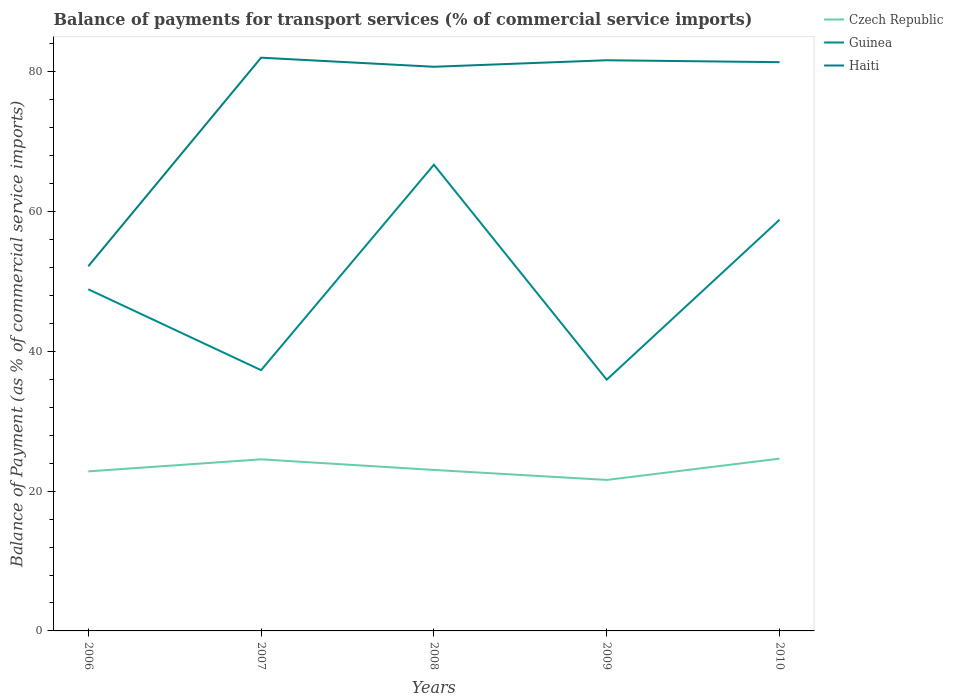Does the line corresponding to Haiti intersect with the line corresponding to Czech Republic?
Offer a terse response. No. Is the number of lines equal to the number of legend labels?
Your answer should be compact. Yes. Across all years, what is the maximum balance of payments for transport services in Haiti?
Provide a succinct answer. 52.17. In which year was the balance of payments for transport services in Czech Republic maximum?
Provide a succinct answer. 2009. What is the total balance of payments for transport services in Haiti in the graph?
Offer a terse response. -29.2. What is the difference between the highest and the second highest balance of payments for transport services in Haiti?
Provide a succinct answer. 29.84. How many lines are there?
Keep it short and to the point. 3. Are the values on the major ticks of Y-axis written in scientific E-notation?
Provide a succinct answer. No. Does the graph contain any zero values?
Your answer should be compact. No. How are the legend labels stacked?
Offer a terse response. Vertical. What is the title of the graph?
Make the answer very short. Balance of payments for transport services (% of commercial service imports). What is the label or title of the X-axis?
Your response must be concise. Years. What is the label or title of the Y-axis?
Provide a short and direct response. Balance of Payment (as % of commercial service imports). What is the Balance of Payment (as % of commercial service imports) of Czech Republic in 2006?
Ensure brevity in your answer.  22.82. What is the Balance of Payment (as % of commercial service imports) in Guinea in 2006?
Your response must be concise. 48.88. What is the Balance of Payment (as % of commercial service imports) of Haiti in 2006?
Provide a short and direct response. 52.17. What is the Balance of Payment (as % of commercial service imports) of Czech Republic in 2007?
Provide a succinct answer. 24.55. What is the Balance of Payment (as % of commercial service imports) in Guinea in 2007?
Keep it short and to the point. 37.31. What is the Balance of Payment (as % of commercial service imports) of Haiti in 2007?
Offer a very short reply. 82.01. What is the Balance of Payment (as % of commercial service imports) in Czech Republic in 2008?
Offer a very short reply. 23.03. What is the Balance of Payment (as % of commercial service imports) in Guinea in 2008?
Make the answer very short. 66.7. What is the Balance of Payment (as % of commercial service imports) in Haiti in 2008?
Keep it short and to the point. 80.71. What is the Balance of Payment (as % of commercial service imports) of Czech Republic in 2009?
Give a very brief answer. 21.6. What is the Balance of Payment (as % of commercial service imports) of Guinea in 2009?
Your response must be concise. 35.94. What is the Balance of Payment (as % of commercial service imports) in Haiti in 2009?
Give a very brief answer. 81.64. What is the Balance of Payment (as % of commercial service imports) of Czech Republic in 2010?
Your answer should be very brief. 24.65. What is the Balance of Payment (as % of commercial service imports) in Guinea in 2010?
Your answer should be very brief. 58.82. What is the Balance of Payment (as % of commercial service imports) in Haiti in 2010?
Offer a very short reply. 81.37. Across all years, what is the maximum Balance of Payment (as % of commercial service imports) in Czech Republic?
Make the answer very short. 24.65. Across all years, what is the maximum Balance of Payment (as % of commercial service imports) in Guinea?
Keep it short and to the point. 66.7. Across all years, what is the maximum Balance of Payment (as % of commercial service imports) of Haiti?
Keep it short and to the point. 82.01. Across all years, what is the minimum Balance of Payment (as % of commercial service imports) of Czech Republic?
Provide a succinct answer. 21.6. Across all years, what is the minimum Balance of Payment (as % of commercial service imports) in Guinea?
Provide a succinct answer. 35.94. Across all years, what is the minimum Balance of Payment (as % of commercial service imports) of Haiti?
Your response must be concise. 52.17. What is the total Balance of Payment (as % of commercial service imports) in Czech Republic in the graph?
Make the answer very short. 116.65. What is the total Balance of Payment (as % of commercial service imports) of Guinea in the graph?
Make the answer very short. 247.64. What is the total Balance of Payment (as % of commercial service imports) in Haiti in the graph?
Your answer should be very brief. 377.9. What is the difference between the Balance of Payment (as % of commercial service imports) in Czech Republic in 2006 and that in 2007?
Your response must be concise. -1.72. What is the difference between the Balance of Payment (as % of commercial service imports) in Guinea in 2006 and that in 2007?
Your answer should be compact. 11.57. What is the difference between the Balance of Payment (as % of commercial service imports) in Haiti in 2006 and that in 2007?
Offer a terse response. -29.84. What is the difference between the Balance of Payment (as % of commercial service imports) of Czech Republic in 2006 and that in 2008?
Provide a succinct answer. -0.2. What is the difference between the Balance of Payment (as % of commercial service imports) in Guinea in 2006 and that in 2008?
Your answer should be very brief. -17.82. What is the difference between the Balance of Payment (as % of commercial service imports) of Haiti in 2006 and that in 2008?
Your answer should be very brief. -28.54. What is the difference between the Balance of Payment (as % of commercial service imports) of Czech Republic in 2006 and that in 2009?
Provide a succinct answer. 1.22. What is the difference between the Balance of Payment (as % of commercial service imports) of Guinea in 2006 and that in 2009?
Offer a terse response. 12.93. What is the difference between the Balance of Payment (as % of commercial service imports) in Haiti in 2006 and that in 2009?
Your answer should be very brief. -29.47. What is the difference between the Balance of Payment (as % of commercial service imports) of Czech Republic in 2006 and that in 2010?
Offer a very short reply. -1.82. What is the difference between the Balance of Payment (as % of commercial service imports) of Guinea in 2006 and that in 2010?
Give a very brief answer. -9.94. What is the difference between the Balance of Payment (as % of commercial service imports) of Haiti in 2006 and that in 2010?
Give a very brief answer. -29.2. What is the difference between the Balance of Payment (as % of commercial service imports) of Czech Republic in 2007 and that in 2008?
Offer a very short reply. 1.52. What is the difference between the Balance of Payment (as % of commercial service imports) in Guinea in 2007 and that in 2008?
Give a very brief answer. -29.39. What is the difference between the Balance of Payment (as % of commercial service imports) of Haiti in 2007 and that in 2008?
Your response must be concise. 1.3. What is the difference between the Balance of Payment (as % of commercial service imports) of Czech Republic in 2007 and that in 2009?
Make the answer very short. 2.95. What is the difference between the Balance of Payment (as % of commercial service imports) of Guinea in 2007 and that in 2009?
Keep it short and to the point. 1.36. What is the difference between the Balance of Payment (as % of commercial service imports) of Haiti in 2007 and that in 2009?
Provide a succinct answer. 0.37. What is the difference between the Balance of Payment (as % of commercial service imports) in Czech Republic in 2007 and that in 2010?
Your answer should be compact. -0.1. What is the difference between the Balance of Payment (as % of commercial service imports) in Guinea in 2007 and that in 2010?
Your answer should be compact. -21.51. What is the difference between the Balance of Payment (as % of commercial service imports) of Haiti in 2007 and that in 2010?
Make the answer very short. 0.64. What is the difference between the Balance of Payment (as % of commercial service imports) of Czech Republic in 2008 and that in 2009?
Give a very brief answer. 1.43. What is the difference between the Balance of Payment (as % of commercial service imports) in Guinea in 2008 and that in 2009?
Your answer should be compact. 30.75. What is the difference between the Balance of Payment (as % of commercial service imports) of Haiti in 2008 and that in 2009?
Keep it short and to the point. -0.93. What is the difference between the Balance of Payment (as % of commercial service imports) of Czech Republic in 2008 and that in 2010?
Provide a short and direct response. -1.62. What is the difference between the Balance of Payment (as % of commercial service imports) in Guinea in 2008 and that in 2010?
Your answer should be compact. 7.88. What is the difference between the Balance of Payment (as % of commercial service imports) of Haiti in 2008 and that in 2010?
Offer a very short reply. -0.66. What is the difference between the Balance of Payment (as % of commercial service imports) of Czech Republic in 2009 and that in 2010?
Give a very brief answer. -3.05. What is the difference between the Balance of Payment (as % of commercial service imports) of Guinea in 2009 and that in 2010?
Provide a short and direct response. -22.88. What is the difference between the Balance of Payment (as % of commercial service imports) in Haiti in 2009 and that in 2010?
Your response must be concise. 0.27. What is the difference between the Balance of Payment (as % of commercial service imports) of Czech Republic in 2006 and the Balance of Payment (as % of commercial service imports) of Guinea in 2007?
Your answer should be compact. -14.48. What is the difference between the Balance of Payment (as % of commercial service imports) in Czech Republic in 2006 and the Balance of Payment (as % of commercial service imports) in Haiti in 2007?
Your response must be concise. -59.18. What is the difference between the Balance of Payment (as % of commercial service imports) of Guinea in 2006 and the Balance of Payment (as % of commercial service imports) of Haiti in 2007?
Provide a short and direct response. -33.13. What is the difference between the Balance of Payment (as % of commercial service imports) of Czech Republic in 2006 and the Balance of Payment (as % of commercial service imports) of Guinea in 2008?
Your answer should be compact. -43.87. What is the difference between the Balance of Payment (as % of commercial service imports) in Czech Republic in 2006 and the Balance of Payment (as % of commercial service imports) in Haiti in 2008?
Your answer should be very brief. -57.89. What is the difference between the Balance of Payment (as % of commercial service imports) of Guinea in 2006 and the Balance of Payment (as % of commercial service imports) of Haiti in 2008?
Make the answer very short. -31.83. What is the difference between the Balance of Payment (as % of commercial service imports) of Czech Republic in 2006 and the Balance of Payment (as % of commercial service imports) of Guinea in 2009?
Provide a succinct answer. -13.12. What is the difference between the Balance of Payment (as % of commercial service imports) of Czech Republic in 2006 and the Balance of Payment (as % of commercial service imports) of Haiti in 2009?
Keep it short and to the point. -58.82. What is the difference between the Balance of Payment (as % of commercial service imports) in Guinea in 2006 and the Balance of Payment (as % of commercial service imports) in Haiti in 2009?
Your answer should be compact. -32.76. What is the difference between the Balance of Payment (as % of commercial service imports) of Czech Republic in 2006 and the Balance of Payment (as % of commercial service imports) of Guinea in 2010?
Keep it short and to the point. -36. What is the difference between the Balance of Payment (as % of commercial service imports) of Czech Republic in 2006 and the Balance of Payment (as % of commercial service imports) of Haiti in 2010?
Your answer should be compact. -58.54. What is the difference between the Balance of Payment (as % of commercial service imports) in Guinea in 2006 and the Balance of Payment (as % of commercial service imports) in Haiti in 2010?
Keep it short and to the point. -32.49. What is the difference between the Balance of Payment (as % of commercial service imports) in Czech Republic in 2007 and the Balance of Payment (as % of commercial service imports) in Guinea in 2008?
Offer a very short reply. -42.15. What is the difference between the Balance of Payment (as % of commercial service imports) in Czech Republic in 2007 and the Balance of Payment (as % of commercial service imports) in Haiti in 2008?
Your answer should be very brief. -56.16. What is the difference between the Balance of Payment (as % of commercial service imports) in Guinea in 2007 and the Balance of Payment (as % of commercial service imports) in Haiti in 2008?
Your answer should be very brief. -43.4. What is the difference between the Balance of Payment (as % of commercial service imports) of Czech Republic in 2007 and the Balance of Payment (as % of commercial service imports) of Guinea in 2009?
Your answer should be compact. -11.39. What is the difference between the Balance of Payment (as % of commercial service imports) of Czech Republic in 2007 and the Balance of Payment (as % of commercial service imports) of Haiti in 2009?
Provide a short and direct response. -57.09. What is the difference between the Balance of Payment (as % of commercial service imports) in Guinea in 2007 and the Balance of Payment (as % of commercial service imports) in Haiti in 2009?
Give a very brief answer. -44.34. What is the difference between the Balance of Payment (as % of commercial service imports) of Czech Republic in 2007 and the Balance of Payment (as % of commercial service imports) of Guinea in 2010?
Offer a terse response. -34.27. What is the difference between the Balance of Payment (as % of commercial service imports) of Czech Republic in 2007 and the Balance of Payment (as % of commercial service imports) of Haiti in 2010?
Offer a terse response. -56.82. What is the difference between the Balance of Payment (as % of commercial service imports) of Guinea in 2007 and the Balance of Payment (as % of commercial service imports) of Haiti in 2010?
Make the answer very short. -44.06. What is the difference between the Balance of Payment (as % of commercial service imports) of Czech Republic in 2008 and the Balance of Payment (as % of commercial service imports) of Guinea in 2009?
Make the answer very short. -12.91. What is the difference between the Balance of Payment (as % of commercial service imports) of Czech Republic in 2008 and the Balance of Payment (as % of commercial service imports) of Haiti in 2009?
Give a very brief answer. -58.61. What is the difference between the Balance of Payment (as % of commercial service imports) of Guinea in 2008 and the Balance of Payment (as % of commercial service imports) of Haiti in 2009?
Keep it short and to the point. -14.94. What is the difference between the Balance of Payment (as % of commercial service imports) in Czech Republic in 2008 and the Balance of Payment (as % of commercial service imports) in Guinea in 2010?
Keep it short and to the point. -35.79. What is the difference between the Balance of Payment (as % of commercial service imports) of Czech Republic in 2008 and the Balance of Payment (as % of commercial service imports) of Haiti in 2010?
Make the answer very short. -58.34. What is the difference between the Balance of Payment (as % of commercial service imports) in Guinea in 2008 and the Balance of Payment (as % of commercial service imports) in Haiti in 2010?
Ensure brevity in your answer.  -14.67. What is the difference between the Balance of Payment (as % of commercial service imports) of Czech Republic in 2009 and the Balance of Payment (as % of commercial service imports) of Guinea in 2010?
Provide a short and direct response. -37.22. What is the difference between the Balance of Payment (as % of commercial service imports) of Czech Republic in 2009 and the Balance of Payment (as % of commercial service imports) of Haiti in 2010?
Offer a very short reply. -59.77. What is the difference between the Balance of Payment (as % of commercial service imports) in Guinea in 2009 and the Balance of Payment (as % of commercial service imports) in Haiti in 2010?
Your answer should be very brief. -45.42. What is the average Balance of Payment (as % of commercial service imports) of Czech Republic per year?
Offer a terse response. 23.33. What is the average Balance of Payment (as % of commercial service imports) in Guinea per year?
Offer a terse response. 49.53. What is the average Balance of Payment (as % of commercial service imports) in Haiti per year?
Provide a succinct answer. 75.58. In the year 2006, what is the difference between the Balance of Payment (as % of commercial service imports) in Czech Republic and Balance of Payment (as % of commercial service imports) in Guinea?
Offer a very short reply. -26.05. In the year 2006, what is the difference between the Balance of Payment (as % of commercial service imports) of Czech Republic and Balance of Payment (as % of commercial service imports) of Haiti?
Offer a very short reply. -29.34. In the year 2006, what is the difference between the Balance of Payment (as % of commercial service imports) in Guinea and Balance of Payment (as % of commercial service imports) in Haiti?
Provide a succinct answer. -3.29. In the year 2007, what is the difference between the Balance of Payment (as % of commercial service imports) of Czech Republic and Balance of Payment (as % of commercial service imports) of Guinea?
Offer a terse response. -12.76. In the year 2007, what is the difference between the Balance of Payment (as % of commercial service imports) of Czech Republic and Balance of Payment (as % of commercial service imports) of Haiti?
Give a very brief answer. -57.46. In the year 2007, what is the difference between the Balance of Payment (as % of commercial service imports) of Guinea and Balance of Payment (as % of commercial service imports) of Haiti?
Your answer should be very brief. -44.7. In the year 2008, what is the difference between the Balance of Payment (as % of commercial service imports) of Czech Republic and Balance of Payment (as % of commercial service imports) of Guinea?
Ensure brevity in your answer.  -43.67. In the year 2008, what is the difference between the Balance of Payment (as % of commercial service imports) in Czech Republic and Balance of Payment (as % of commercial service imports) in Haiti?
Give a very brief answer. -57.68. In the year 2008, what is the difference between the Balance of Payment (as % of commercial service imports) in Guinea and Balance of Payment (as % of commercial service imports) in Haiti?
Your answer should be compact. -14.01. In the year 2009, what is the difference between the Balance of Payment (as % of commercial service imports) of Czech Republic and Balance of Payment (as % of commercial service imports) of Guinea?
Offer a very short reply. -14.34. In the year 2009, what is the difference between the Balance of Payment (as % of commercial service imports) of Czech Republic and Balance of Payment (as % of commercial service imports) of Haiti?
Your answer should be compact. -60.04. In the year 2009, what is the difference between the Balance of Payment (as % of commercial service imports) of Guinea and Balance of Payment (as % of commercial service imports) of Haiti?
Keep it short and to the point. -45.7. In the year 2010, what is the difference between the Balance of Payment (as % of commercial service imports) of Czech Republic and Balance of Payment (as % of commercial service imports) of Guinea?
Make the answer very short. -34.17. In the year 2010, what is the difference between the Balance of Payment (as % of commercial service imports) in Czech Republic and Balance of Payment (as % of commercial service imports) in Haiti?
Keep it short and to the point. -56.72. In the year 2010, what is the difference between the Balance of Payment (as % of commercial service imports) in Guinea and Balance of Payment (as % of commercial service imports) in Haiti?
Provide a short and direct response. -22.55. What is the ratio of the Balance of Payment (as % of commercial service imports) of Czech Republic in 2006 to that in 2007?
Offer a terse response. 0.93. What is the ratio of the Balance of Payment (as % of commercial service imports) of Guinea in 2006 to that in 2007?
Provide a succinct answer. 1.31. What is the ratio of the Balance of Payment (as % of commercial service imports) of Haiti in 2006 to that in 2007?
Your answer should be very brief. 0.64. What is the ratio of the Balance of Payment (as % of commercial service imports) in Guinea in 2006 to that in 2008?
Offer a very short reply. 0.73. What is the ratio of the Balance of Payment (as % of commercial service imports) of Haiti in 2006 to that in 2008?
Keep it short and to the point. 0.65. What is the ratio of the Balance of Payment (as % of commercial service imports) in Czech Republic in 2006 to that in 2009?
Offer a terse response. 1.06. What is the ratio of the Balance of Payment (as % of commercial service imports) of Guinea in 2006 to that in 2009?
Give a very brief answer. 1.36. What is the ratio of the Balance of Payment (as % of commercial service imports) in Haiti in 2006 to that in 2009?
Make the answer very short. 0.64. What is the ratio of the Balance of Payment (as % of commercial service imports) in Czech Republic in 2006 to that in 2010?
Offer a very short reply. 0.93. What is the ratio of the Balance of Payment (as % of commercial service imports) in Guinea in 2006 to that in 2010?
Give a very brief answer. 0.83. What is the ratio of the Balance of Payment (as % of commercial service imports) in Haiti in 2006 to that in 2010?
Offer a terse response. 0.64. What is the ratio of the Balance of Payment (as % of commercial service imports) in Czech Republic in 2007 to that in 2008?
Provide a short and direct response. 1.07. What is the ratio of the Balance of Payment (as % of commercial service imports) in Guinea in 2007 to that in 2008?
Give a very brief answer. 0.56. What is the ratio of the Balance of Payment (as % of commercial service imports) of Haiti in 2007 to that in 2008?
Make the answer very short. 1.02. What is the ratio of the Balance of Payment (as % of commercial service imports) in Czech Republic in 2007 to that in 2009?
Ensure brevity in your answer.  1.14. What is the ratio of the Balance of Payment (as % of commercial service imports) of Guinea in 2007 to that in 2009?
Offer a very short reply. 1.04. What is the ratio of the Balance of Payment (as % of commercial service imports) in Haiti in 2007 to that in 2009?
Your answer should be compact. 1. What is the ratio of the Balance of Payment (as % of commercial service imports) of Czech Republic in 2007 to that in 2010?
Your answer should be very brief. 1. What is the ratio of the Balance of Payment (as % of commercial service imports) in Guinea in 2007 to that in 2010?
Ensure brevity in your answer.  0.63. What is the ratio of the Balance of Payment (as % of commercial service imports) of Haiti in 2007 to that in 2010?
Ensure brevity in your answer.  1.01. What is the ratio of the Balance of Payment (as % of commercial service imports) of Czech Republic in 2008 to that in 2009?
Provide a short and direct response. 1.07. What is the ratio of the Balance of Payment (as % of commercial service imports) in Guinea in 2008 to that in 2009?
Your answer should be compact. 1.86. What is the ratio of the Balance of Payment (as % of commercial service imports) in Haiti in 2008 to that in 2009?
Ensure brevity in your answer.  0.99. What is the ratio of the Balance of Payment (as % of commercial service imports) in Czech Republic in 2008 to that in 2010?
Your answer should be very brief. 0.93. What is the ratio of the Balance of Payment (as % of commercial service imports) in Guinea in 2008 to that in 2010?
Your answer should be very brief. 1.13. What is the ratio of the Balance of Payment (as % of commercial service imports) of Haiti in 2008 to that in 2010?
Your answer should be very brief. 0.99. What is the ratio of the Balance of Payment (as % of commercial service imports) of Czech Republic in 2009 to that in 2010?
Offer a terse response. 0.88. What is the ratio of the Balance of Payment (as % of commercial service imports) in Guinea in 2009 to that in 2010?
Your answer should be very brief. 0.61. What is the difference between the highest and the second highest Balance of Payment (as % of commercial service imports) of Czech Republic?
Provide a succinct answer. 0.1. What is the difference between the highest and the second highest Balance of Payment (as % of commercial service imports) of Guinea?
Offer a very short reply. 7.88. What is the difference between the highest and the second highest Balance of Payment (as % of commercial service imports) of Haiti?
Keep it short and to the point. 0.37. What is the difference between the highest and the lowest Balance of Payment (as % of commercial service imports) of Czech Republic?
Offer a very short reply. 3.05. What is the difference between the highest and the lowest Balance of Payment (as % of commercial service imports) in Guinea?
Your answer should be compact. 30.75. What is the difference between the highest and the lowest Balance of Payment (as % of commercial service imports) in Haiti?
Provide a short and direct response. 29.84. 